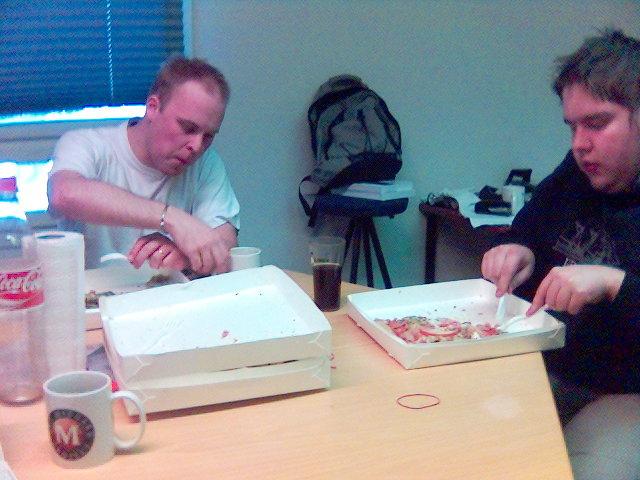What large letter is on the coffee cup?
Concise answer only. M. Are they using plates?
Quick response, please. No. Is it likely these guys are too tired from a long day to cook or wash up dishes?
Short answer required. Yes. 